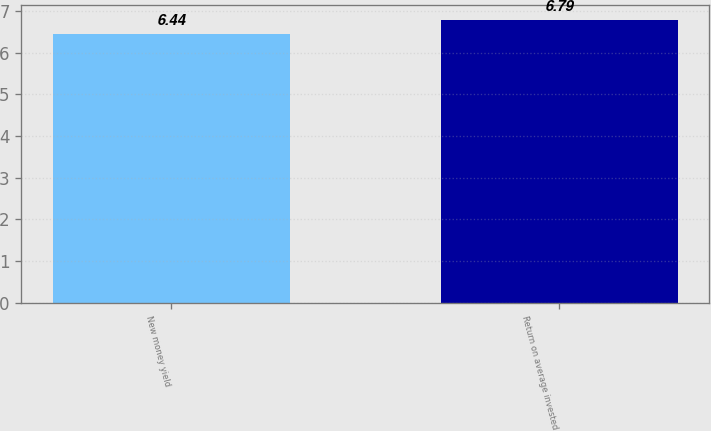Convert chart to OTSL. <chart><loc_0><loc_0><loc_500><loc_500><bar_chart><fcel>New money yield<fcel>Return on average invested<nl><fcel>6.44<fcel>6.79<nl></chart> 